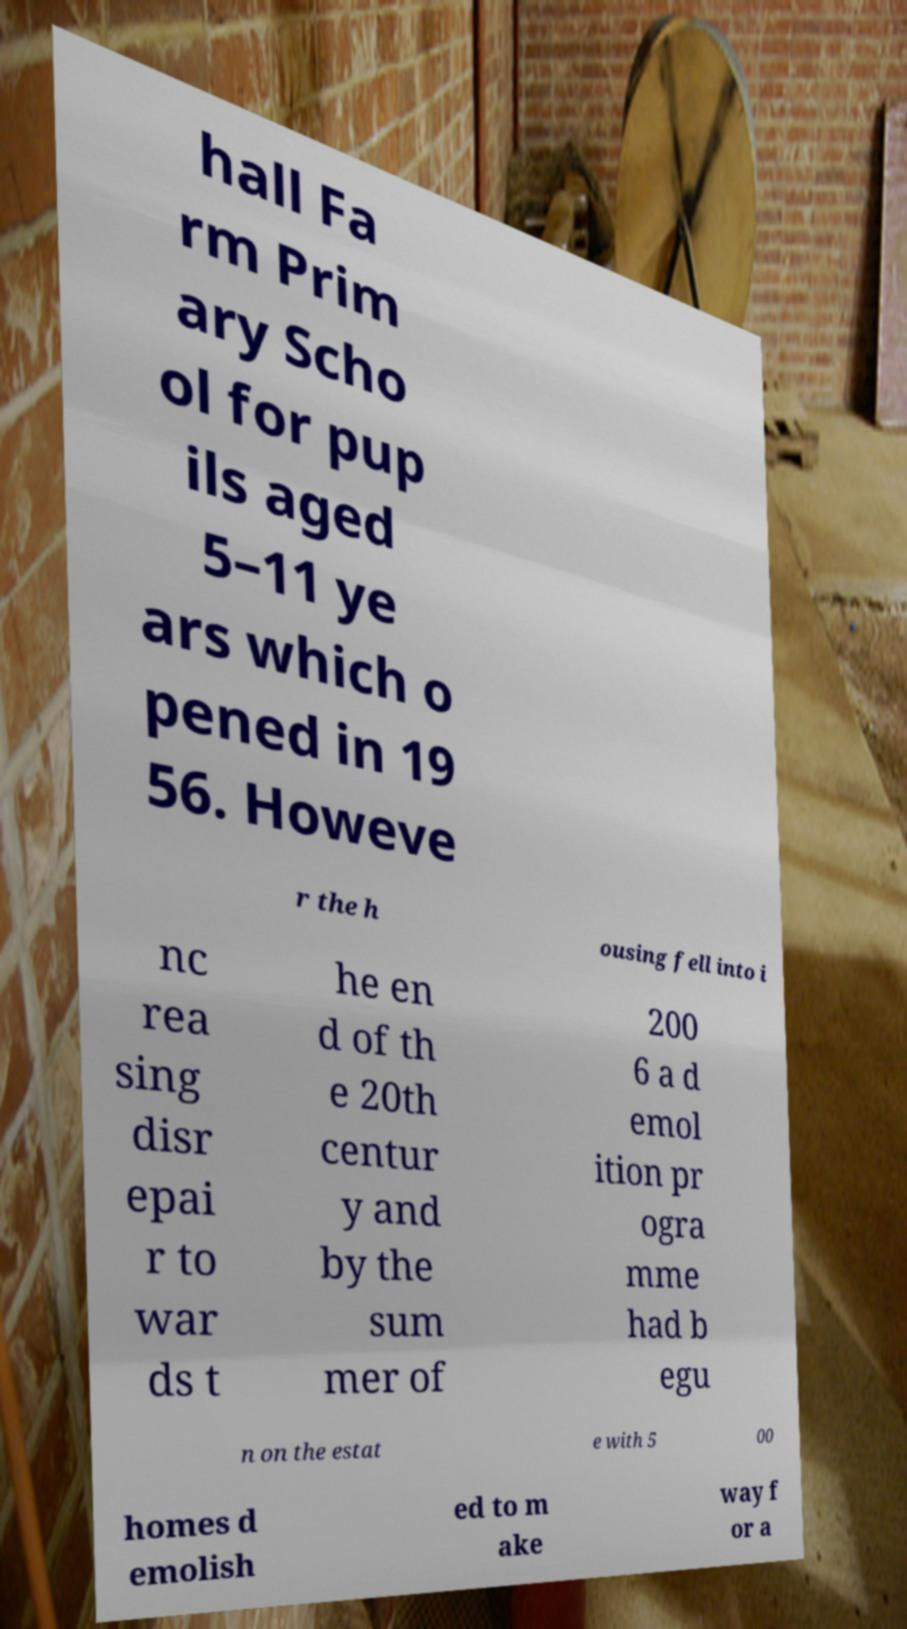Could you assist in decoding the text presented in this image and type it out clearly? hall Fa rm Prim ary Scho ol for pup ils aged 5–11 ye ars which o pened in 19 56. Howeve r the h ousing fell into i nc rea sing disr epai r to war ds t he en d of th e 20th centur y and by the sum mer of 200 6 a d emol ition pr ogra mme had b egu n on the estat e with 5 00 homes d emolish ed to m ake way f or a 